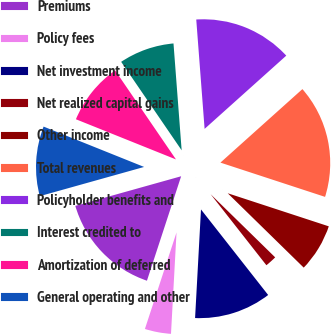Convert chart. <chart><loc_0><loc_0><loc_500><loc_500><pie_chart><fcel>Premiums<fcel>Policy fees<fcel>Net investment income<fcel>Net realized capital gains<fcel>Other income<fcel>Total revenues<fcel>Policyholder benefits and<fcel>Interest credited to<fcel>Amortization of deferred<fcel>General operating and other<nl><fcel>15.62%<fcel>4.17%<fcel>11.46%<fcel>2.08%<fcel>7.29%<fcel>16.67%<fcel>14.58%<fcel>8.33%<fcel>9.38%<fcel>10.42%<nl></chart> 